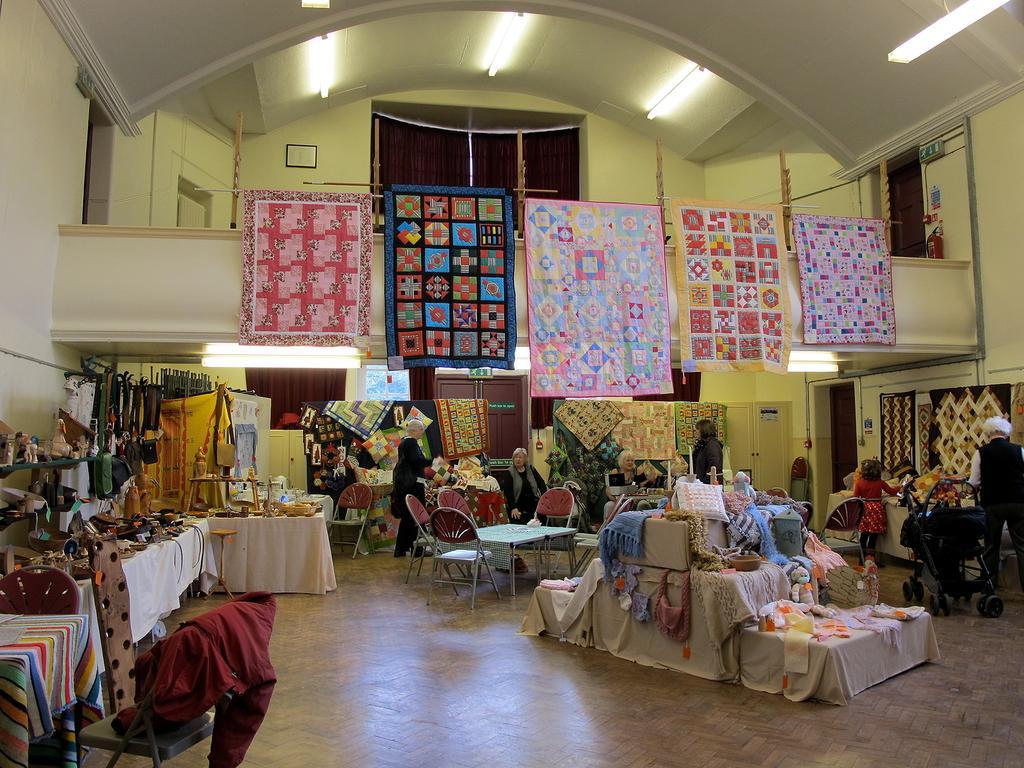How would you summarize this image in a sentence or two? This is clicked inside a building, there are tables on either side of the wall with many clothes,curtains and accessories on it, in the middle there are tables and chairs with clothes on it and above there are bed sheets hanging to a rope and there are lights over the ceiling. 